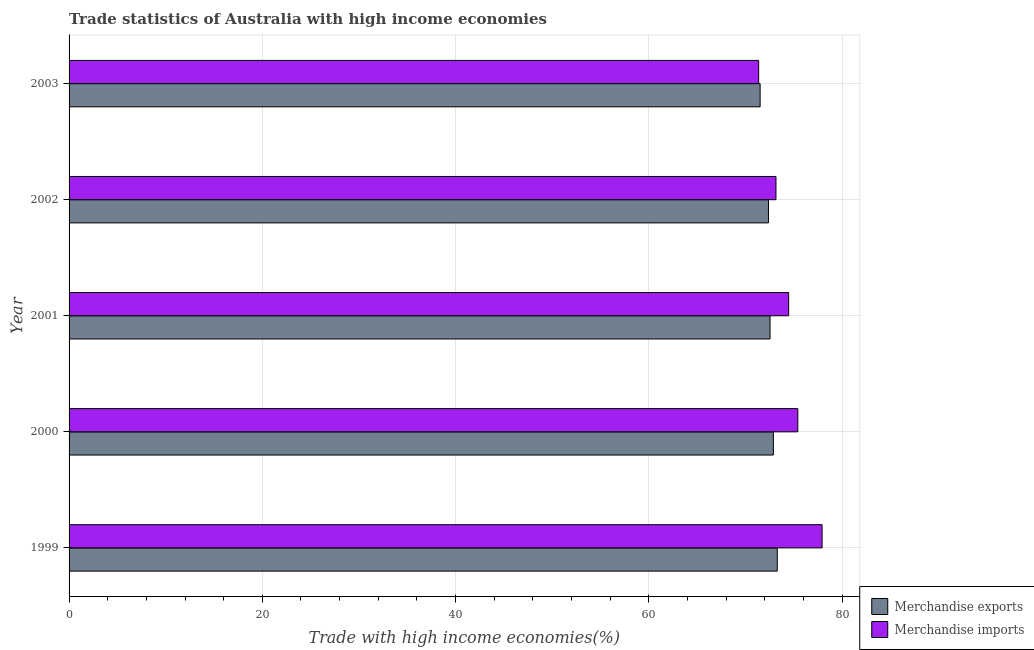How many different coloured bars are there?
Provide a short and direct response. 2. How many groups of bars are there?
Your answer should be very brief. 5. Are the number of bars per tick equal to the number of legend labels?
Make the answer very short. Yes. How many bars are there on the 3rd tick from the top?
Ensure brevity in your answer.  2. What is the label of the 1st group of bars from the top?
Your response must be concise. 2003. What is the merchandise exports in 1999?
Offer a very short reply. 73.29. Across all years, what is the maximum merchandise imports?
Your answer should be compact. 77.93. Across all years, what is the minimum merchandise exports?
Offer a very short reply. 71.52. In which year was the merchandise exports maximum?
Offer a terse response. 1999. In which year was the merchandise imports minimum?
Give a very brief answer. 2003. What is the total merchandise exports in the graph?
Provide a short and direct response. 362.63. What is the difference between the merchandise exports in 2000 and that in 2003?
Give a very brief answer. 1.37. What is the difference between the merchandise imports in 2002 and the merchandise exports in 1999?
Offer a terse response. -0.13. What is the average merchandise imports per year?
Make the answer very short. 74.47. In the year 2002, what is the difference between the merchandise exports and merchandise imports?
Provide a short and direct response. -0.78. What is the ratio of the merchandise exports in 2001 to that in 2002?
Give a very brief answer. 1. Is the merchandise imports in 1999 less than that in 2003?
Offer a very short reply. No. What is the difference between the highest and the second highest merchandise imports?
Your answer should be compact. 2.51. What is the difference between the highest and the lowest merchandise exports?
Provide a short and direct response. 1.77. What does the 1st bar from the top in 2001 represents?
Your answer should be compact. Merchandise imports. How many bars are there?
Your answer should be compact. 10. What is the difference between two consecutive major ticks on the X-axis?
Your answer should be compact. 20. Are the values on the major ticks of X-axis written in scientific E-notation?
Ensure brevity in your answer.  No. How many legend labels are there?
Provide a short and direct response. 2. How are the legend labels stacked?
Your answer should be compact. Vertical. What is the title of the graph?
Your answer should be very brief. Trade statistics of Australia with high income economies. What is the label or title of the X-axis?
Offer a very short reply. Trade with high income economies(%). What is the Trade with high income economies(%) of Merchandise exports in 1999?
Keep it short and to the point. 73.29. What is the Trade with high income economies(%) of Merchandise imports in 1999?
Keep it short and to the point. 77.93. What is the Trade with high income economies(%) in Merchandise exports in 2000?
Ensure brevity in your answer.  72.89. What is the Trade with high income economies(%) in Merchandise imports in 2000?
Give a very brief answer. 75.42. What is the Trade with high income economies(%) in Merchandise exports in 2001?
Offer a very short reply. 72.55. What is the Trade with high income economies(%) of Merchandise imports in 2001?
Provide a short and direct response. 74.47. What is the Trade with high income economies(%) of Merchandise exports in 2002?
Provide a succinct answer. 72.38. What is the Trade with high income economies(%) of Merchandise imports in 2002?
Offer a terse response. 73.16. What is the Trade with high income economies(%) in Merchandise exports in 2003?
Give a very brief answer. 71.52. What is the Trade with high income economies(%) of Merchandise imports in 2003?
Your answer should be very brief. 71.37. Across all years, what is the maximum Trade with high income economies(%) of Merchandise exports?
Your answer should be very brief. 73.29. Across all years, what is the maximum Trade with high income economies(%) of Merchandise imports?
Ensure brevity in your answer.  77.93. Across all years, what is the minimum Trade with high income economies(%) of Merchandise exports?
Offer a very short reply. 71.52. Across all years, what is the minimum Trade with high income economies(%) in Merchandise imports?
Offer a very short reply. 71.37. What is the total Trade with high income economies(%) in Merchandise exports in the graph?
Keep it short and to the point. 362.63. What is the total Trade with high income economies(%) of Merchandise imports in the graph?
Offer a very short reply. 372.35. What is the difference between the Trade with high income economies(%) in Merchandise exports in 1999 and that in 2000?
Keep it short and to the point. 0.4. What is the difference between the Trade with high income economies(%) of Merchandise imports in 1999 and that in 2000?
Offer a terse response. 2.51. What is the difference between the Trade with high income economies(%) of Merchandise exports in 1999 and that in 2001?
Provide a succinct answer. 0.75. What is the difference between the Trade with high income economies(%) of Merchandise imports in 1999 and that in 2001?
Give a very brief answer. 3.46. What is the difference between the Trade with high income economies(%) of Merchandise exports in 1999 and that in 2002?
Your answer should be very brief. 0.91. What is the difference between the Trade with high income economies(%) in Merchandise imports in 1999 and that in 2002?
Your response must be concise. 4.77. What is the difference between the Trade with high income economies(%) in Merchandise exports in 1999 and that in 2003?
Ensure brevity in your answer.  1.77. What is the difference between the Trade with high income economies(%) of Merchandise imports in 1999 and that in 2003?
Offer a very short reply. 6.56. What is the difference between the Trade with high income economies(%) of Merchandise exports in 2000 and that in 2001?
Ensure brevity in your answer.  0.34. What is the difference between the Trade with high income economies(%) in Merchandise imports in 2000 and that in 2001?
Give a very brief answer. 0.95. What is the difference between the Trade with high income economies(%) in Merchandise exports in 2000 and that in 2002?
Provide a short and direct response. 0.51. What is the difference between the Trade with high income economies(%) of Merchandise imports in 2000 and that in 2002?
Provide a succinct answer. 2.26. What is the difference between the Trade with high income economies(%) in Merchandise exports in 2000 and that in 2003?
Provide a succinct answer. 1.37. What is the difference between the Trade with high income economies(%) in Merchandise imports in 2000 and that in 2003?
Give a very brief answer. 4.05. What is the difference between the Trade with high income economies(%) of Merchandise exports in 2001 and that in 2002?
Offer a very short reply. 0.16. What is the difference between the Trade with high income economies(%) of Merchandise imports in 2001 and that in 2002?
Your answer should be very brief. 1.31. What is the difference between the Trade with high income economies(%) of Merchandise imports in 2001 and that in 2003?
Give a very brief answer. 3.1. What is the difference between the Trade with high income economies(%) of Merchandise exports in 2002 and that in 2003?
Your answer should be very brief. 0.86. What is the difference between the Trade with high income economies(%) in Merchandise imports in 2002 and that in 2003?
Provide a short and direct response. 1.79. What is the difference between the Trade with high income economies(%) of Merchandise exports in 1999 and the Trade with high income economies(%) of Merchandise imports in 2000?
Keep it short and to the point. -2.12. What is the difference between the Trade with high income economies(%) in Merchandise exports in 1999 and the Trade with high income economies(%) in Merchandise imports in 2001?
Provide a short and direct response. -1.18. What is the difference between the Trade with high income economies(%) in Merchandise exports in 1999 and the Trade with high income economies(%) in Merchandise imports in 2002?
Make the answer very short. 0.13. What is the difference between the Trade with high income economies(%) in Merchandise exports in 1999 and the Trade with high income economies(%) in Merchandise imports in 2003?
Offer a terse response. 1.93. What is the difference between the Trade with high income economies(%) of Merchandise exports in 2000 and the Trade with high income economies(%) of Merchandise imports in 2001?
Give a very brief answer. -1.58. What is the difference between the Trade with high income economies(%) in Merchandise exports in 2000 and the Trade with high income economies(%) in Merchandise imports in 2002?
Offer a terse response. -0.27. What is the difference between the Trade with high income economies(%) in Merchandise exports in 2000 and the Trade with high income economies(%) in Merchandise imports in 2003?
Your answer should be very brief. 1.52. What is the difference between the Trade with high income economies(%) of Merchandise exports in 2001 and the Trade with high income economies(%) of Merchandise imports in 2002?
Ensure brevity in your answer.  -0.61. What is the difference between the Trade with high income economies(%) of Merchandise exports in 2001 and the Trade with high income economies(%) of Merchandise imports in 2003?
Provide a succinct answer. 1.18. What is the difference between the Trade with high income economies(%) in Merchandise exports in 2002 and the Trade with high income economies(%) in Merchandise imports in 2003?
Keep it short and to the point. 1.02. What is the average Trade with high income economies(%) in Merchandise exports per year?
Provide a succinct answer. 72.53. What is the average Trade with high income economies(%) of Merchandise imports per year?
Give a very brief answer. 74.47. In the year 1999, what is the difference between the Trade with high income economies(%) of Merchandise exports and Trade with high income economies(%) of Merchandise imports?
Keep it short and to the point. -4.64. In the year 2000, what is the difference between the Trade with high income economies(%) of Merchandise exports and Trade with high income economies(%) of Merchandise imports?
Offer a very short reply. -2.53. In the year 2001, what is the difference between the Trade with high income economies(%) in Merchandise exports and Trade with high income economies(%) in Merchandise imports?
Give a very brief answer. -1.93. In the year 2002, what is the difference between the Trade with high income economies(%) of Merchandise exports and Trade with high income economies(%) of Merchandise imports?
Offer a terse response. -0.78. In the year 2003, what is the difference between the Trade with high income economies(%) of Merchandise exports and Trade with high income economies(%) of Merchandise imports?
Keep it short and to the point. 0.15. What is the ratio of the Trade with high income economies(%) of Merchandise exports in 1999 to that in 2000?
Provide a succinct answer. 1.01. What is the ratio of the Trade with high income economies(%) in Merchandise imports in 1999 to that in 2000?
Provide a succinct answer. 1.03. What is the ratio of the Trade with high income economies(%) in Merchandise exports in 1999 to that in 2001?
Your response must be concise. 1.01. What is the ratio of the Trade with high income economies(%) of Merchandise imports in 1999 to that in 2001?
Provide a short and direct response. 1.05. What is the ratio of the Trade with high income economies(%) in Merchandise exports in 1999 to that in 2002?
Ensure brevity in your answer.  1.01. What is the ratio of the Trade with high income economies(%) in Merchandise imports in 1999 to that in 2002?
Offer a terse response. 1.07. What is the ratio of the Trade with high income economies(%) of Merchandise exports in 1999 to that in 2003?
Offer a terse response. 1.02. What is the ratio of the Trade with high income economies(%) in Merchandise imports in 1999 to that in 2003?
Give a very brief answer. 1.09. What is the ratio of the Trade with high income economies(%) of Merchandise exports in 2000 to that in 2001?
Offer a terse response. 1. What is the ratio of the Trade with high income economies(%) in Merchandise imports in 2000 to that in 2001?
Your response must be concise. 1.01. What is the ratio of the Trade with high income economies(%) in Merchandise exports in 2000 to that in 2002?
Ensure brevity in your answer.  1.01. What is the ratio of the Trade with high income economies(%) of Merchandise imports in 2000 to that in 2002?
Provide a short and direct response. 1.03. What is the ratio of the Trade with high income economies(%) in Merchandise exports in 2000 to that in 2003?
Keep it short and to the point. 1.02. What is the ratio of the Trade with high income economies(%) in Merchandise imports in 2000 to that in 2003?
Ensure brevity in your answer.  1.06. What is the ratio of the Trade with high income economies(%) in Merchandise imports in 2001 to that in 2002?
Your answer should be very brief. 1.02. What is the ratio of the Trade with high income economies(%) of Merchandise exports in 2001 to that in 2003?
Offer a terse response. 1.01. What is the ratio of the Trade with high income economies(%) of Merchandise imports in 2001 to that in 2003?
Your answer should be compact. 1.04. What is the ratio of the Trade with high income economies(%) in Merchandise exports in 2002 to that in 2003?
Your answer should be very brief. 1.01. What is the ratio of the Trade with high income economies(%) in Merchandise imports in 2002 to that in 2003?
Provide a short and direct response. 1.03. What is the difference between the highest and the second highest Trade with high income economies(%) in Merchandise exports?
Your answer should be compact. 0.4. What is the difference between the highest and the second highest Trade with high income economies(%) in Merchandise imports?
Your answer should be very brief. 2.51. What is the difference between the highest and the lowest Trade with high income economies(%) of Merchandise exports?
Offer a terse response. 1.77. What is the difference between the highest and the lowest Trade with high income economies(%) in Merchandise imports?
Offer a very short reply. 6.56. 